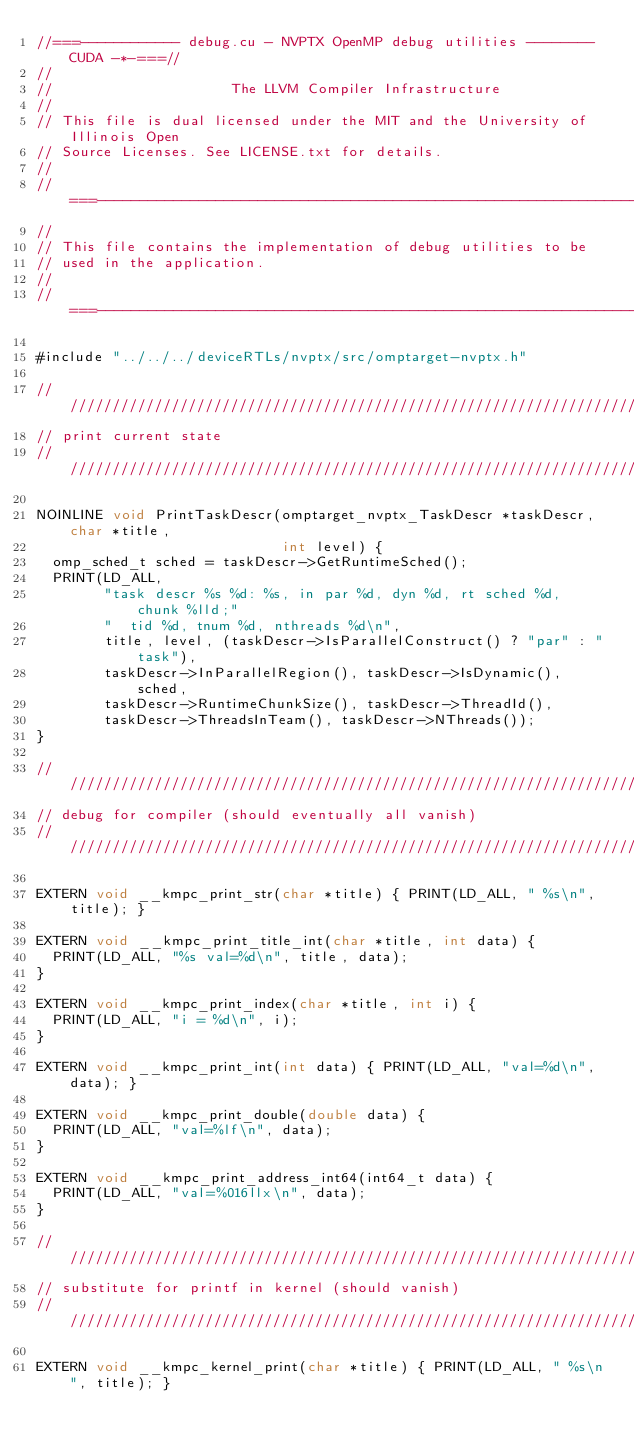Convert code to text. <code><loc_0><loc_0><loc_500><loc_500><_Cuda_>//===------------ debug.cu - NVPTX OpenMP debug utilities -------- CUDA -*-===//
//
//                     The LLVM Compiler Infrastructure
//
// This file is dual licensed under the MIT and the University of Illinois Open
// Source Licenses. See LICENSE.txt for details.
//
//===----------------------------------------------------------------------===//
//
// This file contains the implementation of debug utilities to be
// used in the application.
//
//===----------------------------------------------------------------------===//

#include "../../../deviceRTLs/nvptx/src/omptarget-nvptx.h"

////////////////////////////////////////////////////////////////////////////////
// print current state
////////////////////////////////////////////////////////////////////////////////

NOINLINE void PrintTaskDescr(omptarget_nvptx_TaskDescr *taskDescr, char *title,
                             int level) {
  omp_sched_t sched = taskDescr->GetRuntimeSched();
  PRINT(LD_ALL,
        "task descr %s %d: %s, in par %d, dyn %d, rt sched %d, chunk %lld;"
        "  tid %d, tnum %d, nthreads %d\n",
        title, level, (taskDescr->IsParallelConstruct() ? "par" : "task"),
        taskDescr->InParallelRegion(), taskDescr->IsDynamic(), sched,
        taskDescr->RuntimeChunkSize(), taskDescr->ThreadId(),
        taskDescr->ThreadsInTeam(), taskDescr->NThreads());
}

////////////////////////////////////////////////////////////////////////////////
// debug for compiler (should eventually all vanish)
////////////////////////////////////////////////////////////////////////////////

EXTERN void __kmpc_print_str(char *title) { PRINT(LD_ALL, " %s\n", title); }

EXTERN void __kmpc_print_title_int(char *title, int data) {
  PRINT(LD_ALL, "%s val=%d\n", title, data);
}

EXTERN void __kmpc_print_index(char *title, int i) {
  PRINT(LD_ALL, "i = %d\n", i);
}

EXTERN void __kmpc_print_int(int data) { PRINT(LD_ALL, "val=%d\n", data); }

EXTERN void __kmpc_print_double(double data) {
  PRINT(LD_ALL, "val=%lf\n", data);
}

EXTERN void __kmpc_print_address_int64(int64_t data) {
  PRINT(LD_ALL, "val=%016llx\n", data);
}

////////////////////////////////////////////////////////////////////////////////
// substitute for printf in kernel (should vanish)
////////////////////////////////////////////////////////////////////////////////

EXTERN void __kmpc_kernel_print(char *title) { PRINT(LD_ALL, " %s\n", title); }
</code> 